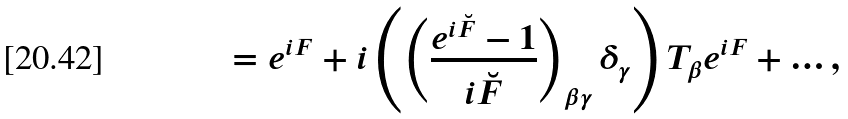<formula> <loc_0><loc_0><loc_500><loc_500>= e ^ { i F } + i \left ( \left ( \frac { e ^ { i \breve { F } } - 1 } { i \breve { F } } \right ) _ { \beta \gamma } \delta _ { \gamma } \right ) T _ { \beta } e ^ { i F } + \dots ,</formula> 